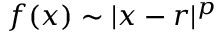Convert formula to latex. <formula><loc_0><loc_0><loc_500><loc_500>f ( x ) \sim | x - r | ^ { p }</formula> 